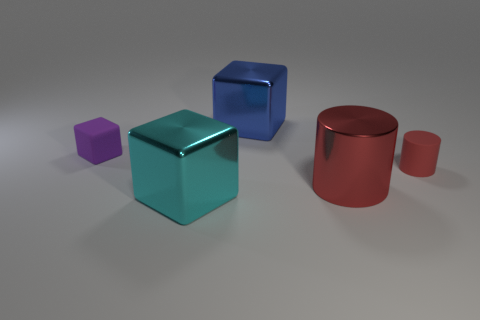Do the large blue cube behind the purple matte block and the tiny purple object have the same material?
Make the answer very short. No. What number of cubes have the same size as the matte cylinder?
Keep it short and to the point. 1. Is the number of large metallic blocks that are in front of the red matte object greater than the number of tiny red matte cylinders left of the blue shiny thing?
Give a very brief answer. Yes. Are there any other matte objects that have the same shape as the large red object?
Provide a short and direct response. Yes. What size is the metal object that is to the right of the cube that is behind the small rubber block?
Make the answer very short. Large. What shape is the shiny thing to the left of the cube behind the matte object that is behind the tiny red thing?
Offer a terse response. Cube. What size is the block that is made of the same material as the small red thing?
Offer a terse response. Small. Is the number of red matte cylinders greater than the number of matte things?
Your answer should be compact. No. There is a cyan thing that is the same size as the red metallic object; what is its material?
Ensure brevity in your answer.  Metal. There is a block that is to the left of the cyan metal object; does it have the same size as the tiny red cylinder?
Your answer should be compact. Yes. 